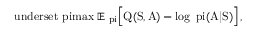Convert formula to latex. <formula><loc_0><loc_0><loc_500><loc_500>\ u n d e r s e t { \ p i } { \max } \, \mathbb { E } _ { \ p i } \left [ Q ( S , A ) - \log \, \ p i ( A | S ) \right ] \, ,</formula> 